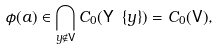<formula> <loc_0><loc_0><loc_500><loc_500>\phi ( a ) \in \bigcap _ { y \notin \mathsf V } C _ { 0 } ( \mathsf Y \ \{ y \} ) = C _ { 0 } ( \mathsf V ) ,</formula> 